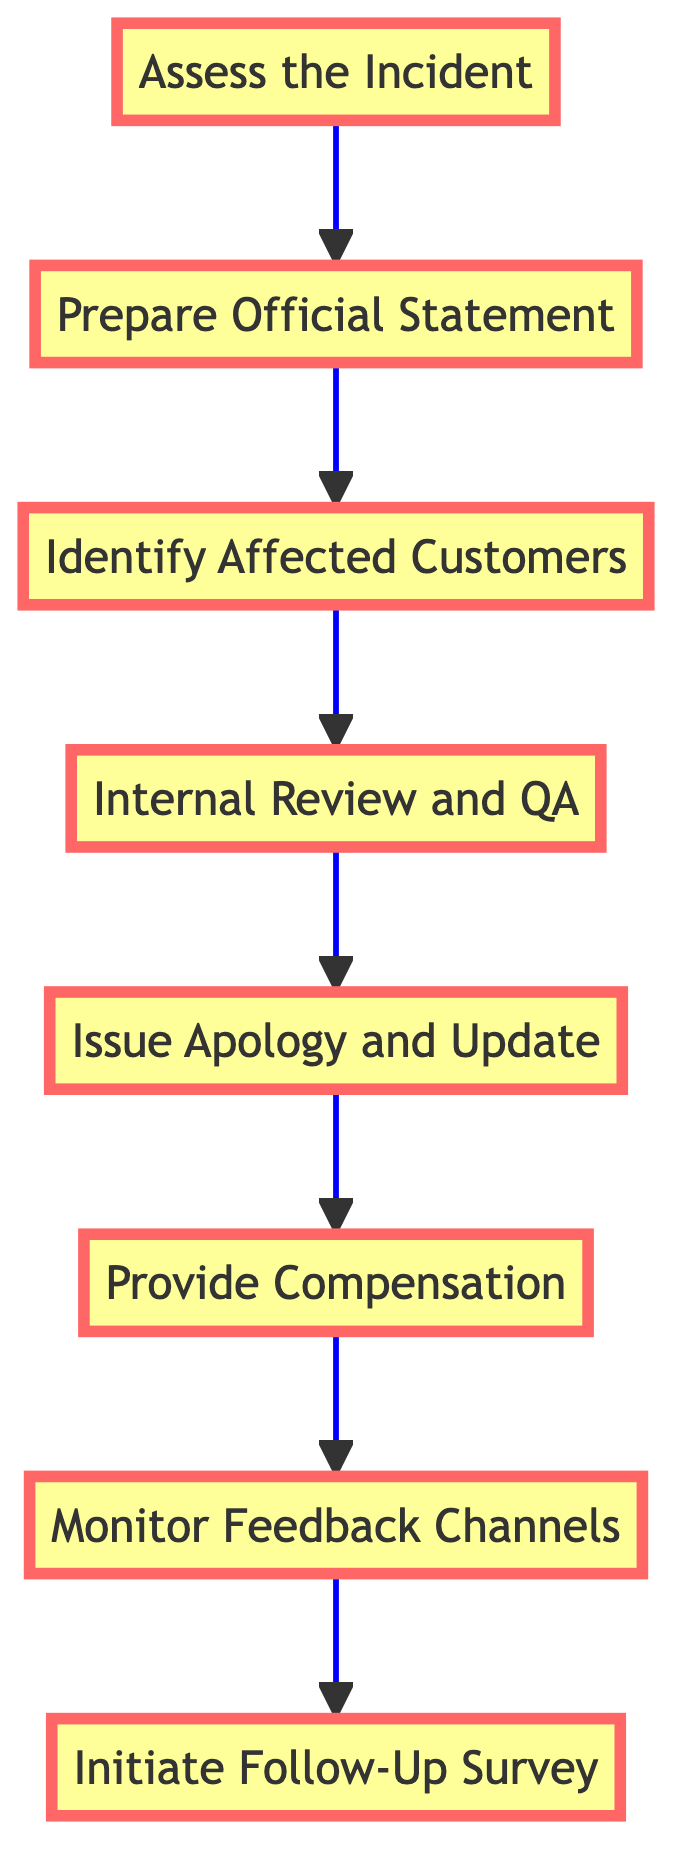What is the first step in the protocol? The first step in the protocol, as seen at the bottom of the flowchart, is "Assess the Incident." This initiates the process which leads to all subsequent actions.
Answer: Assess the Incident How many total steps are in the protocol? Counting each node in the flowchart, there are eight distinct steps involved in the protocol.
Answer: Eight What is the action associated with "Issue Apology and Update"? The action linked to "Issue Apology and Update" is to "Publicly issue an apology and provide updates on corrective actions taken by the company." This provides clarity on what the company intends to do at this stage of the protocol.
Answer: Publicly issue an apology and provide updates on corrective actions taken by the company Which step comes after "Provide Compensation"? According to the flow of the diagram, the next step that follows "Provide Compensation" is "Monitor Feedback Channels." This shows the progression from offering compensation to actively seeking feedback.
Answer: Monitor Feedback Channels What is the relationship between "Prepare Official Statement" and "Assess the Incident"? The relationship between "Prepare Official Statement" and "Assess the Incident" is sequential; “Prepare Official Statement” follows directly after “Assess the Incident” in the flowchart. This means that a review of the incident must occur before a statement can be drafted.
Answer: Sequential relationship What overall action is indicated at the end of the flowchart? The final action indicated at the end of the flowchart is "Initiate Follow-Up Survey," suggesting that the protocol culminates with gathering customer feedback post-incident.
Answer: Initiate Follow-Up Survey How does the flow of this diagram indicate a customer-centric approach? The flowchart demonstrates a customer-centric approach by including steps such as providing compensation and monitoring feedback channels, which directly address the concerns of affected customers. This shows that the company's process is designed to prioritize customer experience and satisfaction post-scandal.
Answer: Customer-centric approach indicated Which steps involve communication with customers explicitly? The steps involving direct communication with customers explicitly are "Issue Apology and Update," "Provide Compensation," and "Initiate Follow-Up Survey," each focused on informing and directly interacting with those affected.
Answer: Three steps 